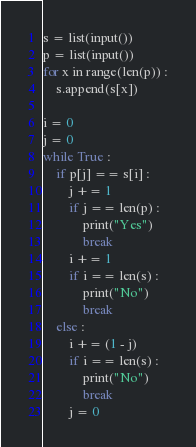<code> <loc_0><loc_0><loc_500><loc_500><_Python_>s = list(input())
p = list(input())
for x in range(len(p)) :
    s.append(s[x])

i = 0
j = 0
while True :
    if p[j] == s[i] :
        j += 1
        if j == len(p) :
            print("Yes")
            break
        i += 1
        if i == len(s) :
            print("No")
            break
    else :
        i += (1 - j)
        if i == len(s) :
            print("No")
            break
        j = 0

</code> 